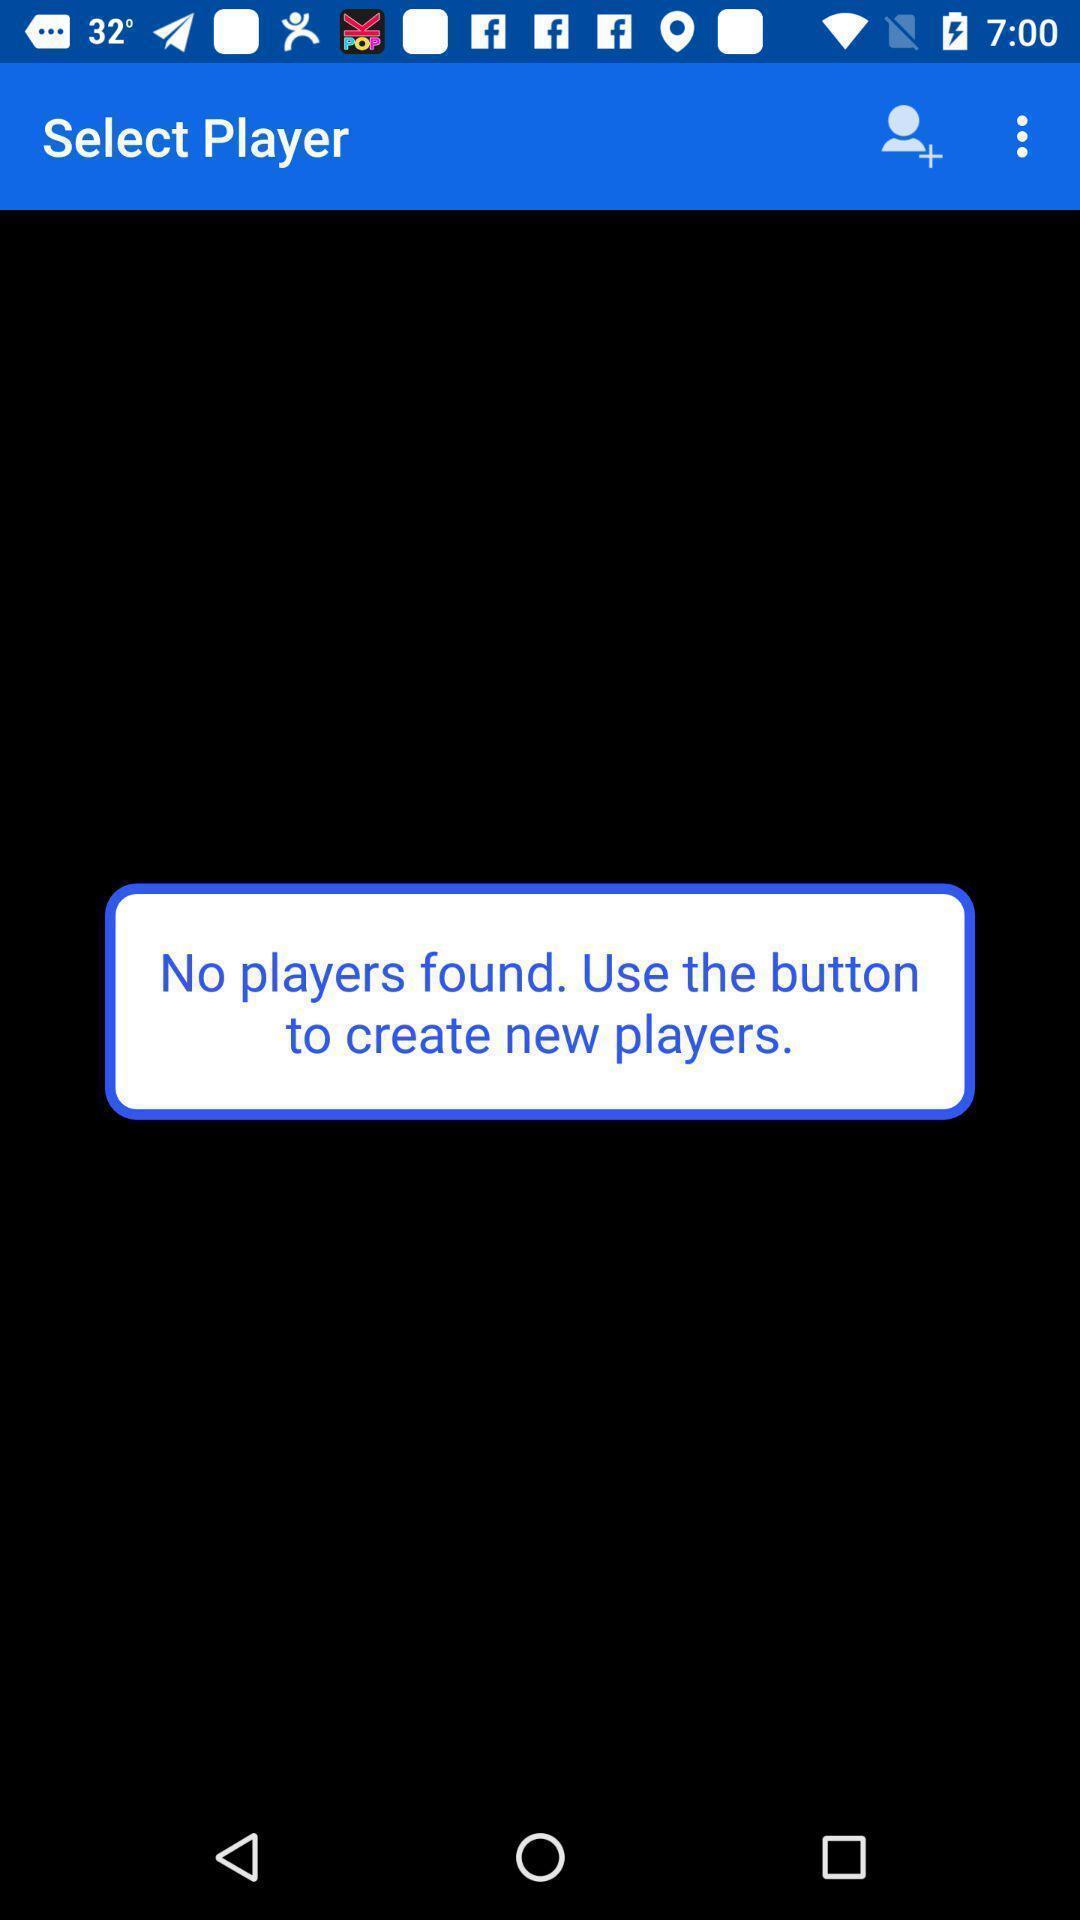Summarize the main components in this picture. Select a player page in a game app. 